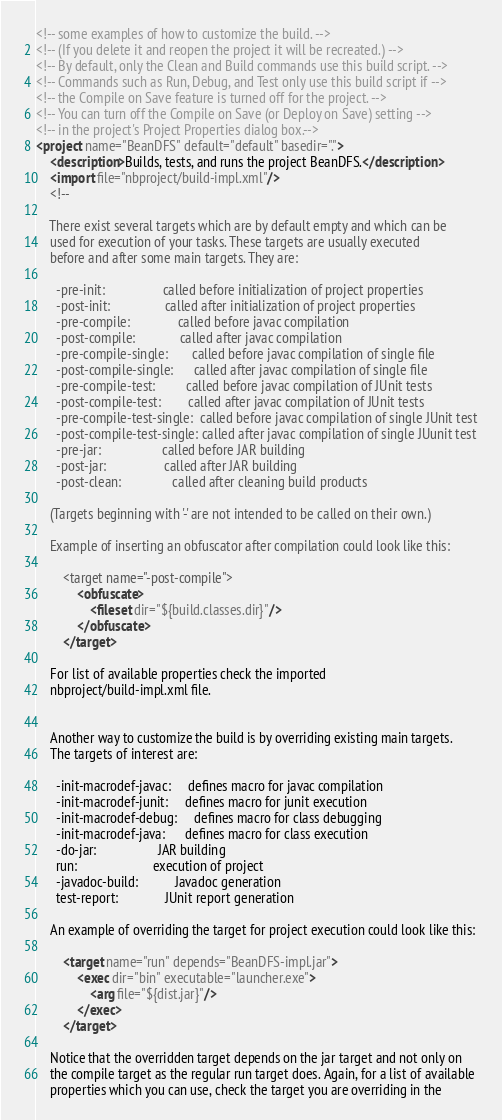<code> <loc_0><loc_0><loc_500><loc_500><_XML_><!-- some examples of how to customize the build. -->
<!-- (If you delete it and reopen the project it will be recreated.) -->
<!-- By default, only the Clean and Build commands use this build script. -->
<!-- Commands such as Run, Debug, and Test only use this build script if -->
<!-- the Compile on Save feature is turned off for the project. -->
<!-- You can turn off the Compile on Save (or Deploy on Save) setting -->
<!-- in the project's Project Properties dialog box.-->
<project name="BeanDFS" default="default" basedir=".">
    <description>Builds, tests, and runs the project BeanDFS.</description>
    <import file="nbproject/build-impl.xml"/>
    <!--

    There exist several targets which are by default empty and which can be 
    used for execution of your tasks. These targets are usually executed 
    before and after some main targets. They are: 

      -pre-init:                 called before initialization of project properties
      -post-init:                called after initialization of project properties
      -pre-compile:              called before javac compilation
      -post-compile:             called after javac compilation
      -pre-compile-single:       called before javac compilation of single file
      -post-compile-single:      called after javac compilation of single file
      -pre-compile-test:         called before javac compilation of JUnit tests
      -post-compile-test:        called after javac compilation of JUnit tests
      -pre-compile-test-single:  called before javac compilation of single JUnit test
      -post-compile-test-single: called after javac compilation of single JUunit test
      -pre-jar:                  called before JAR building
      -post-jar:                 called after JAR building
      -post-clean:               called after cleaning build products

    (Targets beginning with '-' are not intended to be called on their own.)

    Example of inserting an obfuscator after compilation could look like this:

        <target name="-post-compile">
            <obfuscate>
                <fileset dir="${build.classes.dir}"/>
            </obfuscate>
        </target>

    For list of available properties check the imported 
    nbproject/build-impl.xml file. 


    Another way to customize the build is by overriding existing main targets.
    The targets of interest are: 

      -init-macrodef-javac:     defines macro for javac compilation
      -init-macrodef-junit:     defines macro for junit execution
      -init-macrodef-debug:     defines macro for class debugging
      -init-macrodef-java:      defines macro for class execution
      -do-jar:                  JAR building
      run:                      execution of project 
      -javadoc-build:           Javadoc generation
      test-report:              JUnit report generation

    An example of overriding the target for project execution could look like this:

        <target name="run" depends="BeanDFS-impl.jar">
            <exec dir="bin" executable="launcher.exe">
                <arg file="${dist.jar}"/>
            </exec>
        </target>

    Notice that the overridden target depends on the jar target and not only on 
    the compile target as the regular run target does. Again, for a list of available 
    properties which you can use, check the target you are overriding in the</code> 